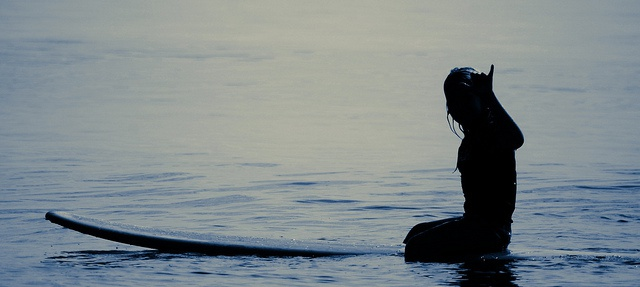Describe the objects in this image and their specific colors. I can see people in gray, black, darkgray, navy, and darkblue tones and surfboard in gray, black, and darkgray tones in this image. 